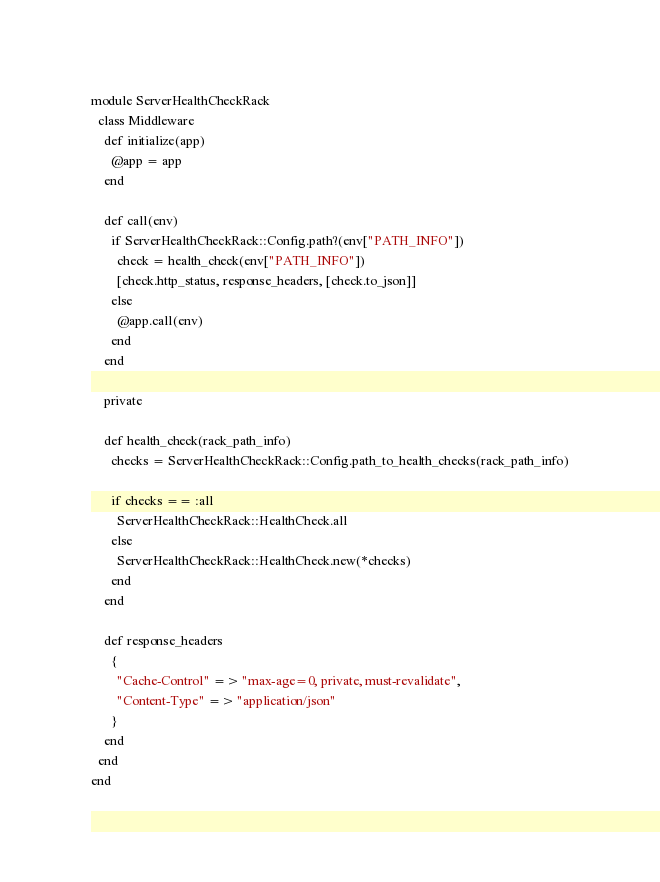<code> <loc_0><loc_0><loc_500><loc_500><_Ruby_>module ServerHealthCheckRack
  class Middleware
    def initialize(app)
      @app = app
    end

    def call(env)
      if ServerHealthCheckRack::Config.path?(env["PATH_INFO"])
        check = health_check(env["PATH_INFO"])
        [check.http_status, response_headers, [check.to_json]]
      else
        @app.call(env)
      end
    end

    private

    def health_check(rack_path_info)
      checks = ServerHealthCheckRack::Config.path_to_health_checks(rack_path_info)

      if checks == :all
        ServerHealthCheckRack::HealthCheck.all
      else
        ServerHealthCheckRack::HealthCheck.new(*checks)
      end
    end

    def response_headers
      {
        "Cache-Control" => "max-age=0, private, must-revalidate",
        "Content-Type" => "application/json"
      }
    end
  end
end
</code> 